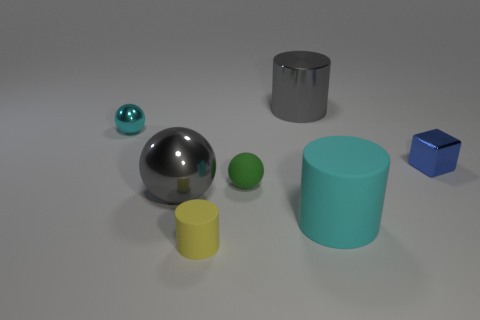Add 2 big gray objects. How many objects exist? 9 Subtract all cylinders. How many objects are left? 4 Subtract 0 cyan blocks. How many objects are left? 7 Subtract all yellow cylinders. Subtract all yellow matte cylinders. How many objects are left? 5 Add 5 blocks. How many blocks are left? 6 Add 2 tiny cylinders. How many tiny cylinders exist? 3 